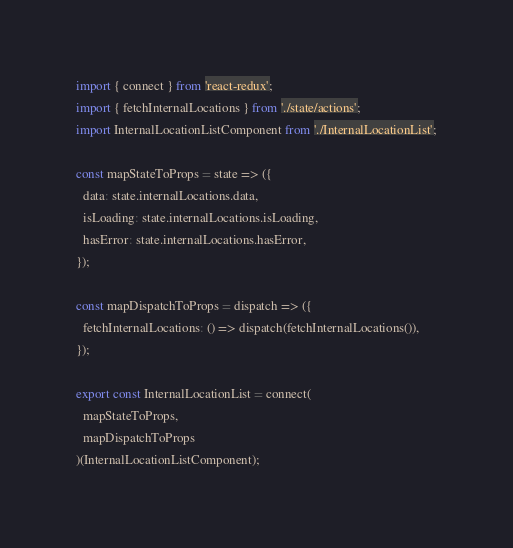<code> <loc_0><loc_0><loc_500><loc_500><_JavaScript_>import { connect } from 'react-redux';
import { fetchInternalLocations } from './state/actions';
import InternalLocationListComponent from './InternalLocationList';

const mapStateToProps = state => ({
  data: state.internalLocations.data,
  isLoading: state.internalLocations.isLoading,
  hasError: state.internalLocations.hasError,
});

const mapDispatchToProps = dispatch => ({
  fetchInternalLocations: () => dispatch(fetchInternalLocations()),
});

export const InternalLocationList = connect(
  mapStateToProps,
  mapDispatchToProps
)(InternalLocationListComponent);
</code> 